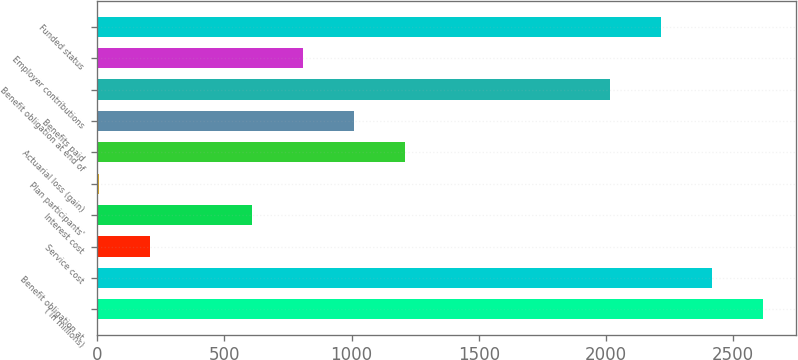Convert chart. <chart><loc_0><loc_0><loc_500><loc_500><bar_chart><fcel>( in millions)<fcel>Benefit obligation at<fcel>Service cost<fcel>Interest cost<fcel>Plan participants'<fcel>Actuarial loss (gain)<fcel>Benefits paid<fcel>Benefit obligation at end of<fcel>Employer contributions<fcel>Funded status<nl><fcel>2617.7<fcel>2416.8<fcel>206.9<fcel>608.7<fcel>6<fcel>1211.4<fcel>1010.5<fcel>2015<fcel>809.6<fcel>2215.9<nl></chart> 